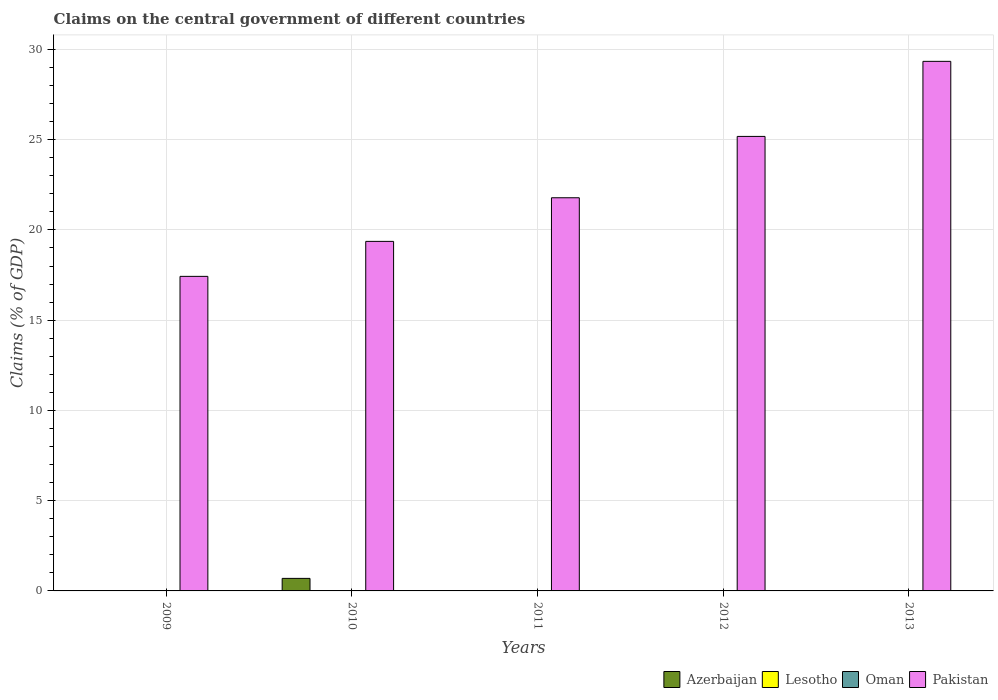How many different coloured bars are there?
Provide a succinct answer. 2. Are the number of bars per tick equal to the number of legend labels?
Your response must be concise. No. Are the number of bars on each tick of the X-axis equal?
Your response must be concise. No. How many bars are there on the 3rd tick from the left?
Provide a succinct answer. 1. How many bars are there on the 5th tick from the right?
Provide a succinct answer. 1. In how many cases, is the number of bars for a given year not equal to the number of legend labels?
Provide a short and direct response. 5. What is the percentage of GDP claimed on the central government in Azerbaijan in 2013?
Your response must be concise. 0. Across all years, what is the maximum percentage of GDP claimed on the central government in Pakistan?
Ensure brevity in your answer.  29.34. What is the total percentage of GDP claimed on the central government in Pakistan in the graph?
Provide a short and direct response. 113.09. What is the difference between the percentage of GDP claimed on the central government in Pakistan in 2012 and that in 2013?
Provide a succinct answer. -4.16. What is the difference between the percentage of GDP claimed on the central government in Lesotho in 2010 and the percentage of GDP claimed on the central government in Oman in 2009?
Your answer should be very brief. 0. What is the ratio of the percentage of GDP claimed on the central government in Pakistan in 2009 to that in 2013?
Your response must be concise. 0.59. What is the difference between the highest and the second highest percentage of GDP claimed on the central government in Pakistan?
Your answer should be very brief. 4.16. What is the difference between the highest and the lowest percentage of GDP claimed on the central government in Pakistan?
Make the answer very short. 11.91. In how many years, is the percentage of GDP claimed on the central government in Azerbaijan greater than the average percentage of GDP claimed on the central government in Azerbaijan taken over all years?
Your answer should be compact. 1. How many bars are there?
Give a very brief answer. 6. Does the graph contain any zero values?
Give a very brief answer. Yes. Does the graph contain grids?
Ensure brevity in your answer.  Yes. Where does the legend appear in the graph?
Ensure brevity in your answer.  Bottom right. How many legend labels are there?
Your answer should be very brief. 4. What is the title of the graph?
Keep it short and to the point. Claims on the central government of different countries. What is the label or title of the Y-axis?
Keep it short and to the point. Claims (% of GDP). What is the Claims (% of GDP) in Azerbaijan in 2009?
Your response must be concise. 0. What is the Claims (% of GDP) of Oman in 2009?
Offer a terse response. 0. What is the Claims (% of GDP) in Pakistan in 2009?
Provide a succinct answer. 17.43. What is the Claims (% of GDP) of Azerbaijan in 2010?
Keep it short and to the point. 0.69. What is the Claims (% of GDP) in Lesotho in 2010?
Offer a terse response. 0. What is the Claims (% of GDP) of Pakistan in 2010?
Ensure brevity in your answer.  19.36. What is the Claims (% of GDP) in Lesotho in 2011?
Your answer should be very brief. 0. What is the Claims (% of GDP) of Oman in 2011?
Ensure brevity in your answer.  0. What is the Claims (% of GDP) in Pakistan in 2011?
Make the answer very short. 21.78. What is the Claims (% of GDP) of Azerbaijan in 2012?
Your answer should be very brief. 0. What is the Claims (% of GDP) in Oman in 2012?
Give a very brief answer. 0. What is the Claims (% of GDP) in Pakistan in 2012?
Offer a terse response. 25.18. What is the Claims (% of GDP) in Azerbaijan in 2013?
Make the answer very short. 0. What is the Claims (% of GDP) of Pakistan in 2013?
Your response must be concise. 29.34. Across all years, what is the maximum Claims (% of GDP) in Azerbaijan?
Provide a short and direct response. 0.69. Across all years, what is the maximum Claims (% of GDP) of Pakistan?
Your response must be concise. 29.34. Across all years, what is the minimum Claims (% of GDP) in Pakistan?
Ensure brevity in your answer.  17.43. What is the total Claims (% of GDP) of Azerbaijan in the graph?
Your answer should be very brief. 0.69. What is the total Claims (% of GDP) of Lesotho in the graph?
Provide a succinct answer. 0. What is the total Claims (% of GDP) of Pakistan in the graph?
Ensure brevity in your answer.  113.09. What is the difference between the Claims (% of GDP) in Pakistan in 2009 and that in 2010?
Give a very brief answer. -1.94. What is the difference between the Claims (% of GDP) in Pakistan in 2009 and that in 2011?
Your response must be concise. -4.35. What is the difference between the Claims (% of GDP) of Pakistan in 2009 and that in 2012?
Ensure brevity in your answer.  -7.75. What is the difference between the Claims (% of GDP) of Pakistan in 2009 and that in 2013?
Ensure brevity in your answer.  -11.91. What is the difference between the Claims (% of GDP) in Pakistan in 2010 and that in 2011?
Keep it short and to the point. -2.42. What is the difference between the Claims (% of GDP) in Pakistan in 2010 and that in 2012?
Ensure brevity in your answer.  -5.82. What is the difference between the Claims (% of GDP) in Pakistan in 2010 and that in 2013?
Offer a terse response. -9.97. What is the difference between the Claims (% of GDP) in Pakistan in 2011 and that in 2012?
Give a very brief answer. -3.4. What is the difference between the Claims (% of GDP) of Pakistan in 2011 and that in 2013?
Your answer should be very brief. -7.56. What is the difference between the Claims (% of GDP) of Pakistan in 2012 and that in 2013?
Ensure brevity in your answer.  -4.16. What is the difference between the Claims (% of GDP) in Azerbaijan in 2010 and the Claims (% of GDP) in Pakistan in 2011?
Offer a terse response. -21.09. What is the difference between the Claims (% of GDP) of Azerbaijan in 2010 and the Claims (% of GDP) of Pakistan in 2012?
Provide a short and direct response. -24.49. What is the difference between the Claims (% of GDP) of Azerbaijan in 2010 and the Claims (% of GDP) of Pakistan in 2013?
Provide a short and direct response. -28.64. What is the average Claims (% of GDP) of Azerbaijan per year?
Make the answer very short. 0.14. What is the average Claims (% of GDP) in Lesotho per year?
Your answer should be very brief. 0. What is the average Claims (% of GDP) in Oman per year?
Provide a succinct answer. 0. What is the average Claims (% of GDP) in Pakistan per year?
Make the answer very short. 22.62. In the year 2010, what is the difference between the Claims (% of GDP) in Azerbaijan and Claims (% of GDP) in Pakistan?
Your answer should be compact. -18.67. What is the ratio of the Claims (% of GDP) of Pakistan in 2009 to that in 2010?
Give a very brief answer. 0.9. What is the ratio of the Claims (% of GDP) of Pakistan in 2009 to that in 2011?
Your answer should be very brief. 0.8. What is the ratio of the Claims (% of GDP) in Pakistan in 2009 to that in 2012?
Your answer should be compact. 0.69. What is the ratio of the Claims (% of GDP) in Pakistan in 2009 to that in 2013?
Give a very brief answer. 0.59. What is the ratio of the Claims (% of GDP) of Pakistan in 2010 to that in 2011?
Your answer should be compact. 0.89. What is the ratio of the Claims (% of GDP) of Pakistan in 2010 to that in 2012?
Ensure brevity in your answer.  0.77. What is the ratio of the Claims (% of GDP) of Pakistan in 2010 to that in 2013?
Your answer should be very brief. 0.66. What is the ratio of the Claims (% of GDP) of Pakistan in 2011 to that in 2012?
Your answer should be very brief. 0.86. What is the ratio of the Claims (% of GDP) in Pakistan in 2011 to that in 2013?
Give a very brief answer. 0.74. What is the ratio of the Claims (% of GDP) of Pakistan in 2012 to that in 2013?
Keep it short and to the point. 0.86. What is the difference between the highest and the second highest Claims (% of GDP) of Pakistan?
Provide a short and direct response. 4.16. What is the difference between the highest and the lowest Claims (% of GDP) in Azerbaijan?
Offer a terse response. 0.69. What is the difference between the highest and the lowest Claims (% of GDP) in Pakistan?
Make the answer very short. 11.91. 